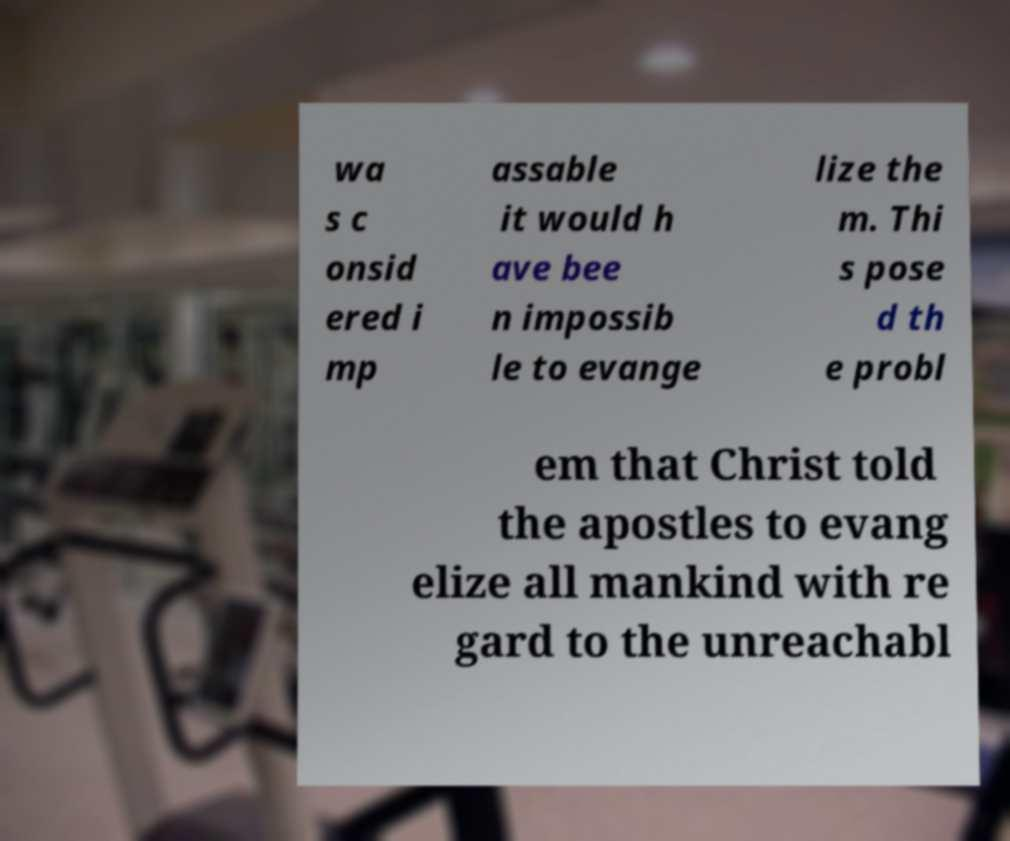Could you assist in decoding the text presented in this image and type it out clearly? wa s c onsid ered i mp assable it would h ave bee n impossib le to evange lize the m. Thi s pose d th e probl em that Christ told the apostles to evang elize all mankind with re gard to the unreachabl 